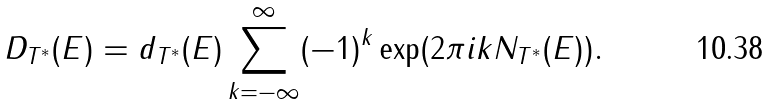<formula> <loc_0><loc_0><loc_500><loc_500>D _ { T ^ { * } } ( E ) = d _ { T ^ { * } } ( E ) \sum _ { k = - \infty } ^ { \infty } ( - 1 ) ^ { k } \exp ( 2 \pi i k N _ { T ^ { * } } ( E ) ) .</formula> 